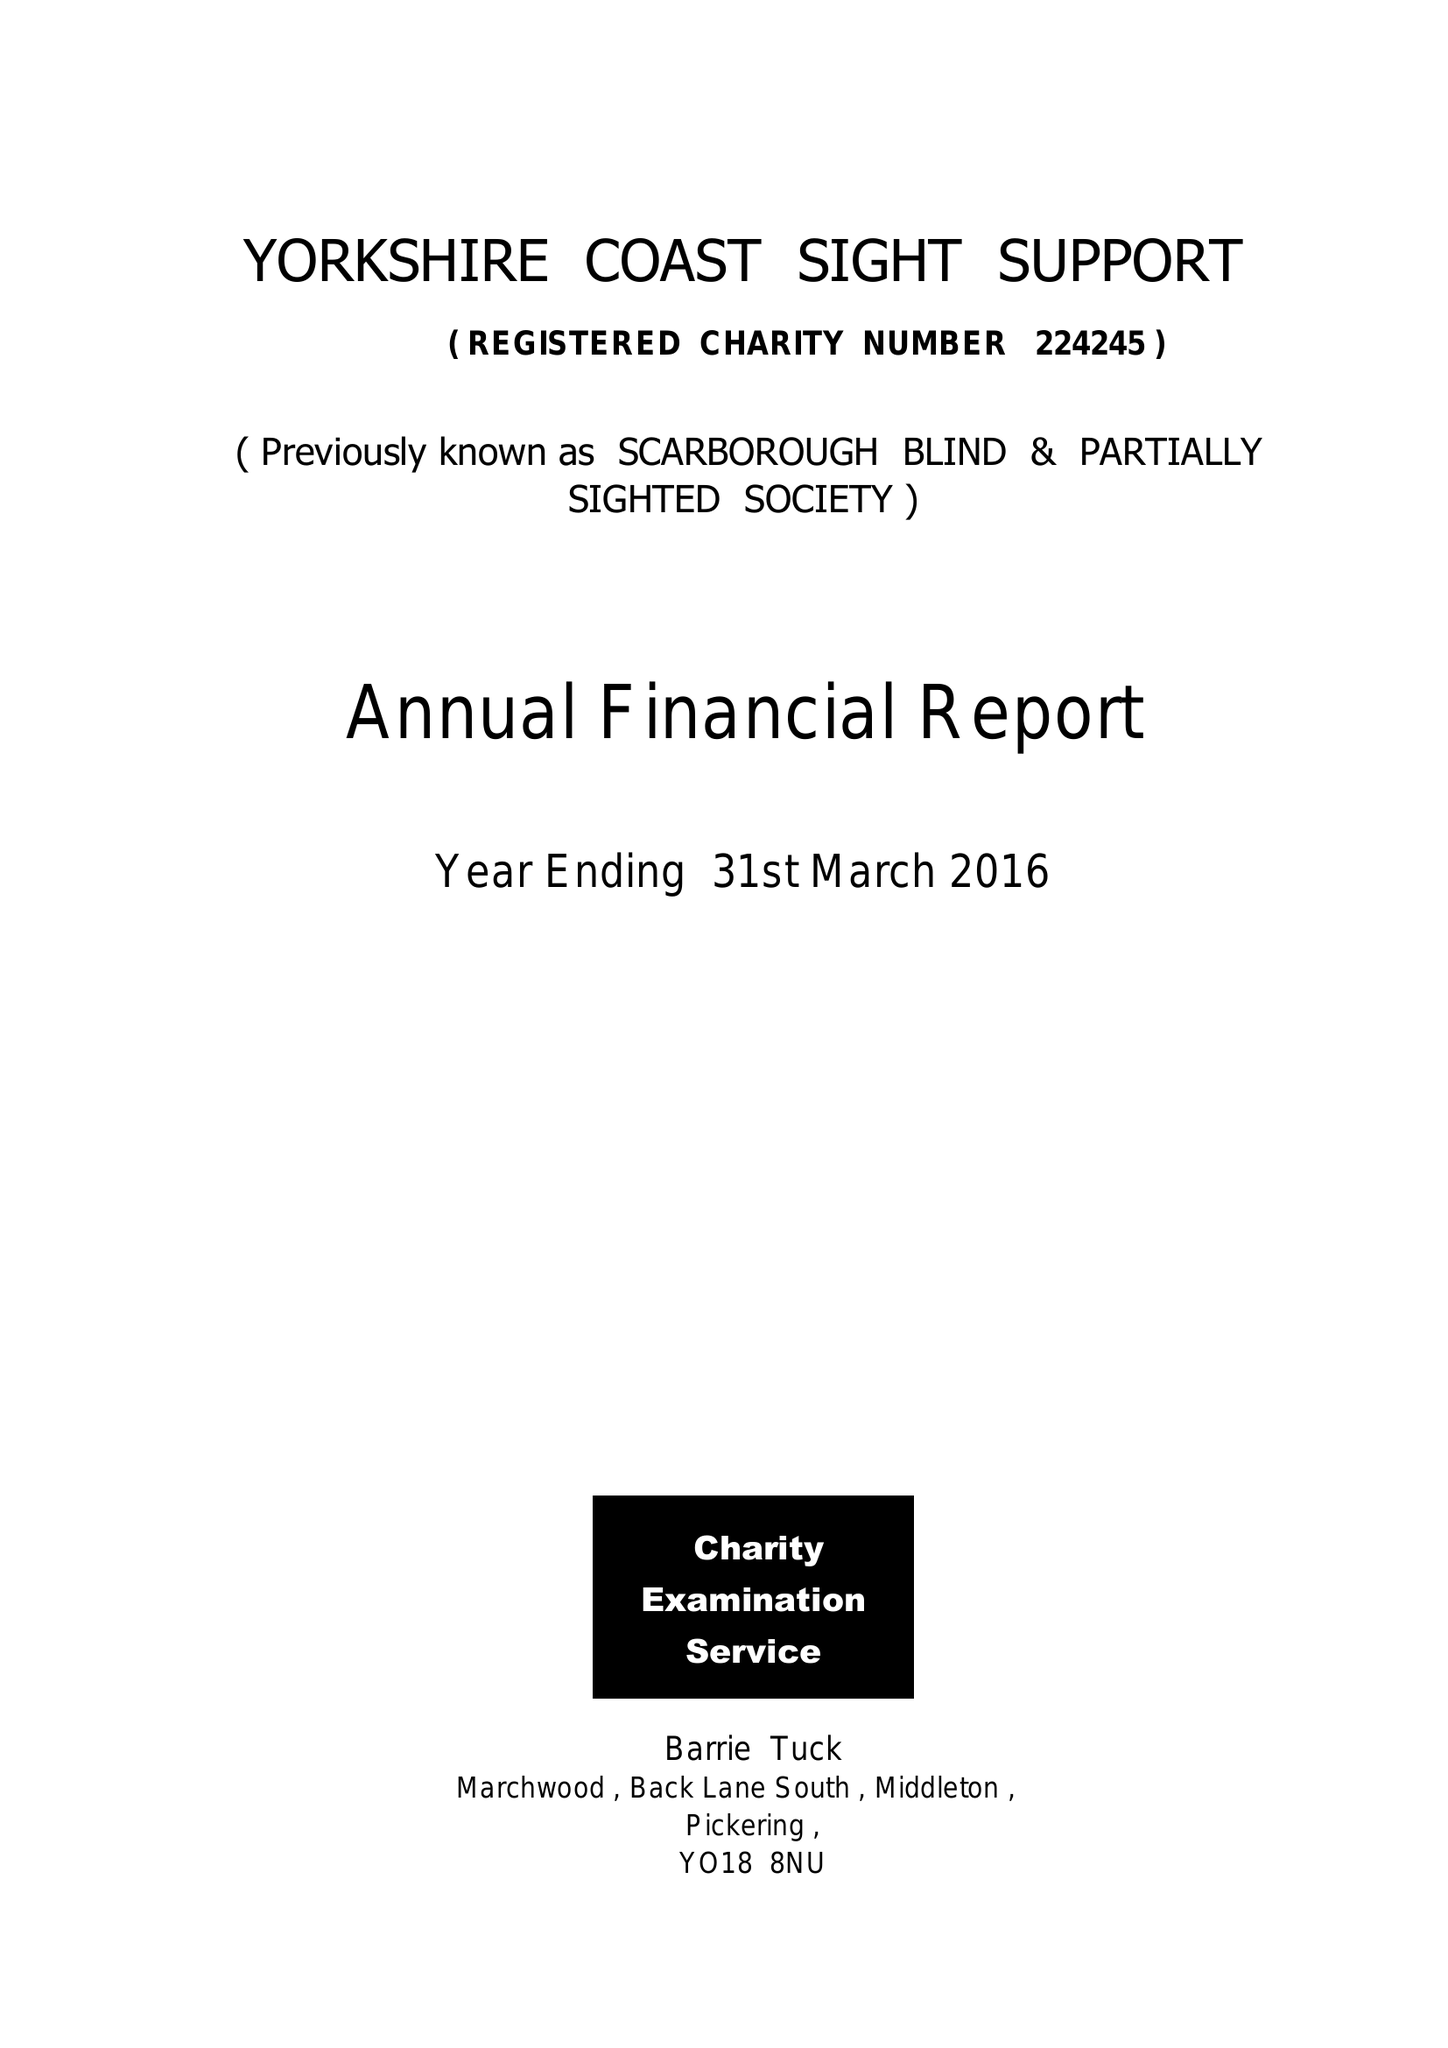What is the value for the income_annually_in_british_pounds?
Answer the question using a single word or phrase. 82935.00 